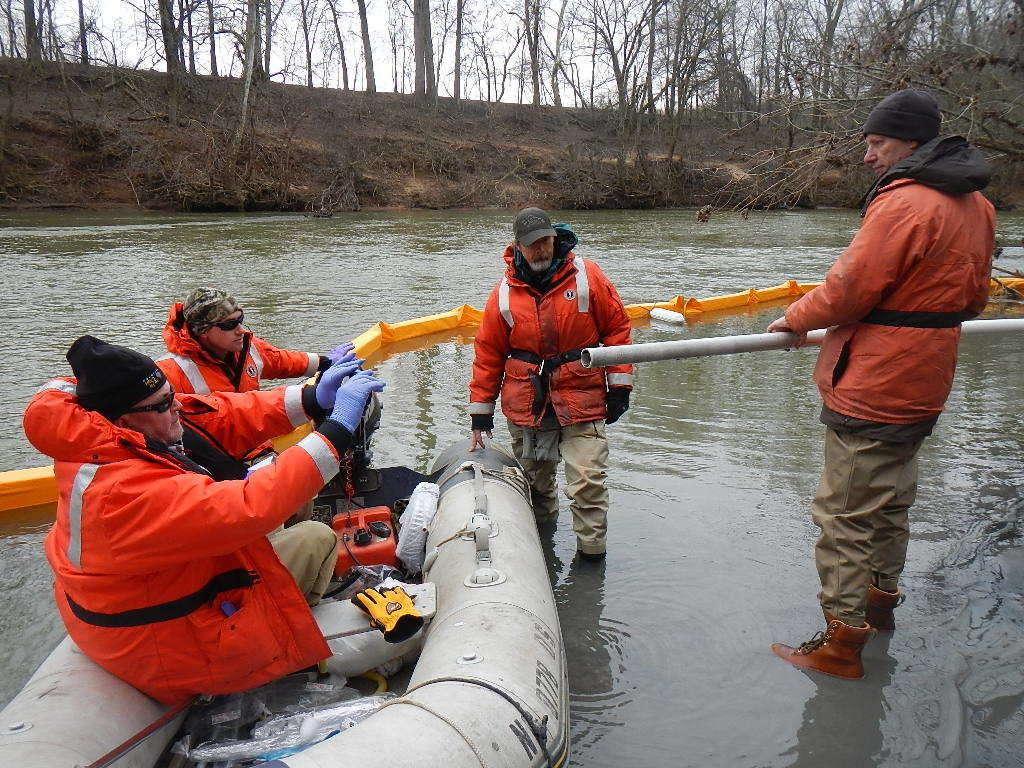How many people are in the image? There are four persons in the image. What are two of the persons doing in the image? Two of the persons are sitting on a boat. What is one person holding in the image? One person is holding a pipe. What is present in the boat with the people? There is a glove in the boat. What type of water body is visible in the image? The image shows a river. What type of vegetation can be seen in the image? Trees are visible in the image. Reasoning: Let' Let's think step by step in order to produce the conversation. We start by identifying the number of people in the image and their activities, such as sitting on a boat. Then, we mention the specific object one person is holding, which is a pipe. Next, we describe the additional item found in the boat, which is a glove. We then identify the type of water body shown in the image, which is a river. Finally, we mention the type of vegetation visible, which are trees. Absurd Question/Answer: Can you tell me which person in the image has the best sense of harmony? The image does not provide information about the sense of harmony of the persons in the image, so it cannot be determined. What type of rock is the person holding in the image? There is no rock present in the image; one person is holding a pipe. 